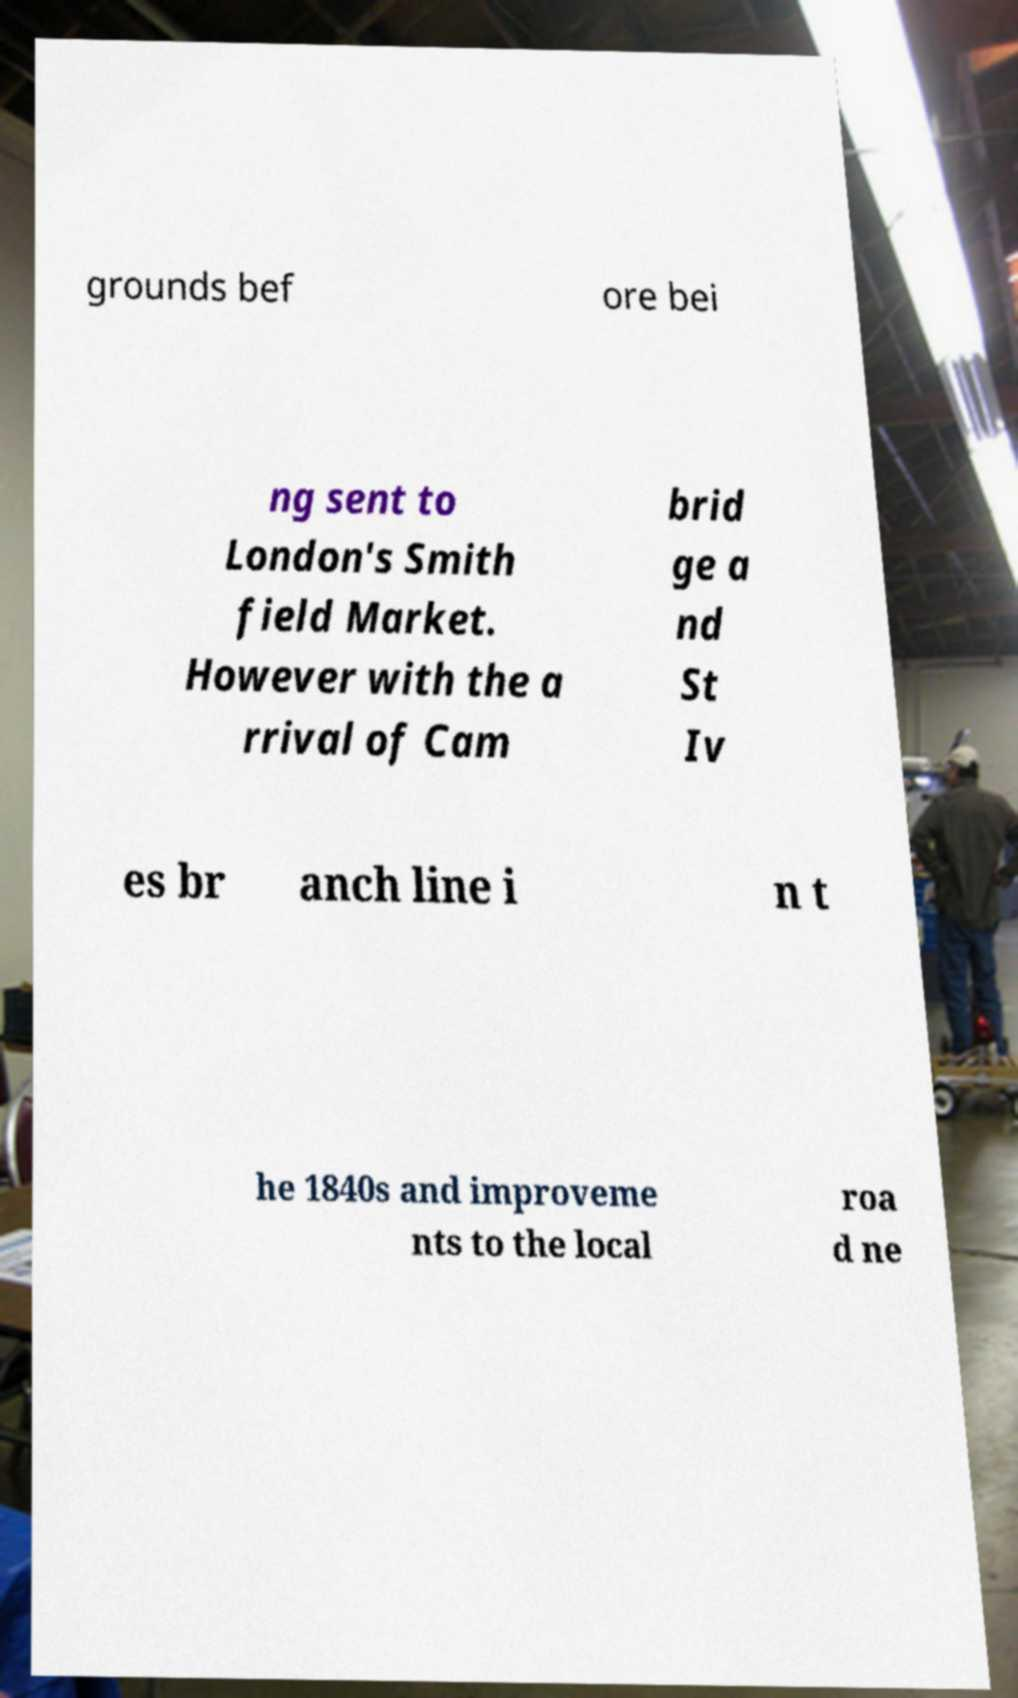For documentation purposes, I need the text within this image transcribed. Could you provide that? grounds bef ore bei ng sent to London's Smith field Market. However with the a rrival of Cam brid ge a nd St Iv es br anch line i n t he 1840s and improveme nts to the local roa d ne 